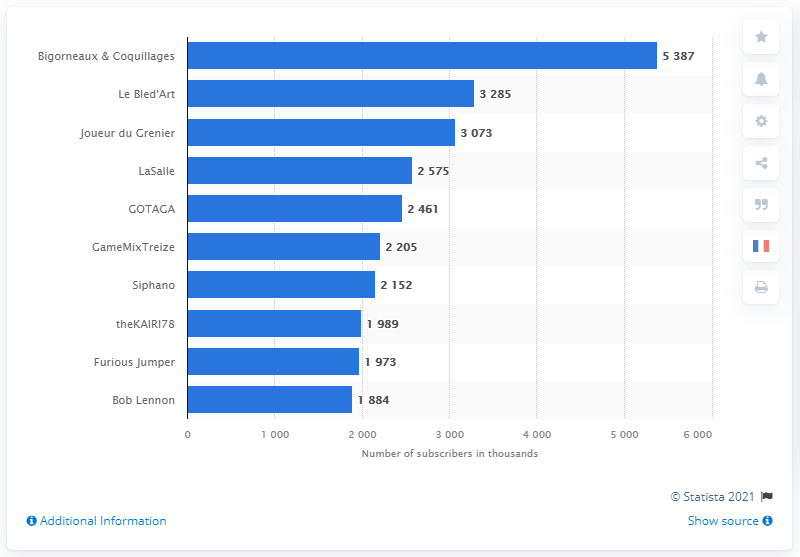Mention a couple of crucial points in this snapshot. The most subscribed French YouTube gaming channel in June 2018 was Bigorneaux & Coquillages. In June 2018, the French YouTube gaming channel that received the most subscribers was Le Bled'Art. 